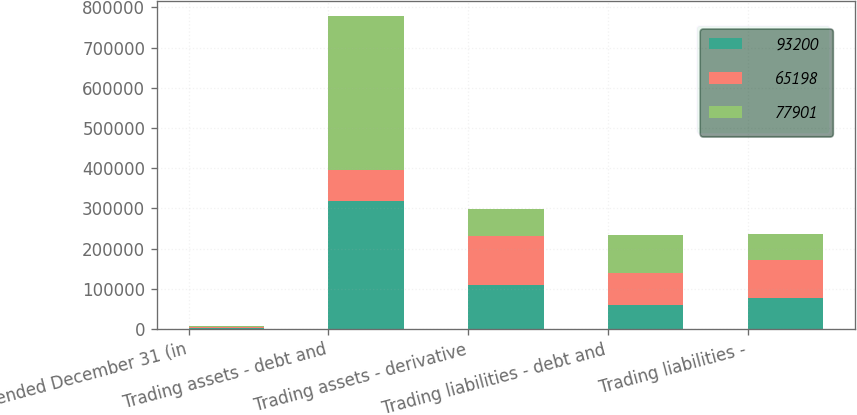<chart> <loc_0><loc_0><loc_500><loc_500><stacked_bar_chart><ecel><fcel>Year ended December 31 (in<fcel>Trading assets - debt and<fcel>Trading assets - derivative<fcel>Trading liabilities - debt and<fcel>Trading liabilities -<nl><fcel>93200<fcel>2009<fcel>318063<fcel>110457<fcel>60224<fcel>77901<nl><fcel>65198<fcel>2008<fcel>78371<fcel>121417<fcel>78841<fcel>93200<nl><fcel>77901<fcel>2007<fcel>381415<fcel>65439<fcel>94737<fcel>65198<nl></chart> 